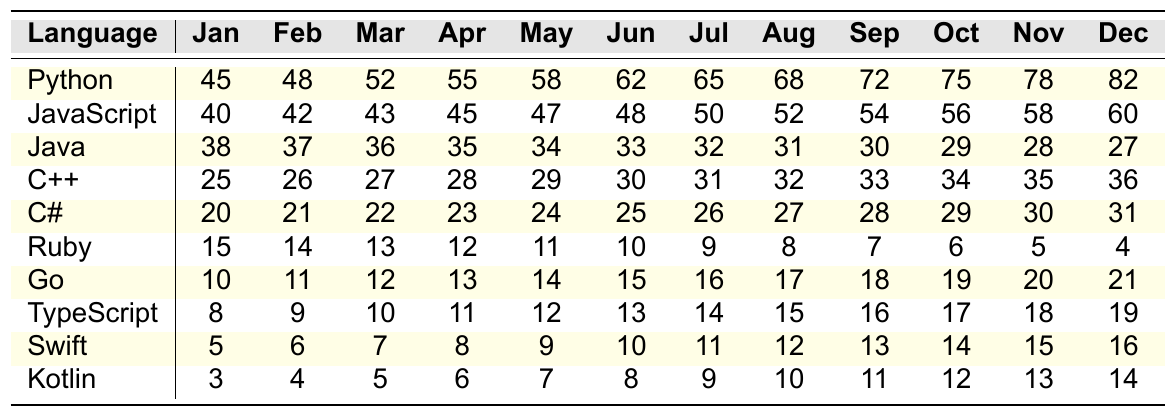What programming language showed the highest popularity in October? In October, Python has the highest value at 75, which is more than any other programming language listed.
Answer: Python Which programming language has the lowest popularity in January? In January, Kotlin has the lowest value at 3, which is the smallest among all programming languages for that month.
Answer: Kotlin What was the average popularity of JavaScript over the year? The values for JavaScript are (40 + 42 + 43 + 45 + 47 + 48 + 50 + 52 + 54 + 56 + 58 + 60) =  582. Dividing by 12 months gives an average of 582/12 = 48.5.
Answer: 48.5 Which programming language had the steepest increase in popularity from June to July? Python had an increase from 62 in June to 65 in July, while the increases for others were smaller. Notably, Go also had an increase from 15 in June to 16 in July, but Python's increase is the largest at +3.
Answer: Python Did Ruby's popularity ever exceed 20 during the year? No, Ruby's highest value is 15, which is less than 20 throughout the year.
Answer: No What is the total popularity of C++ across all months? The total popularity of C++ is calculated by summing its monthly values (25 + 26 + 27 + 28 + 29 + 30 + 31 + 32 + 33 + 34 + 35 + 36) =  366.
Answer: 366 Which language had a consistent decline in popularity every month? Java's values decreased consistently from 38 in January to 27 in December, indicating a downward trend month over month.
Answer: Java How much more popular was Python than Kotlin in December? In December, Python's popularity was 82 while Kotlin's was 14. The difference is calculated as 82 - 14 = 68.
Answer: 68 Which programming language increased in popularity every month from January to December? Go showed a steady increase every month, starting from 10 in January to 21 in December.
Answer: Go What was the total popularity of the two most popular languages (Python and JavaScript) in August? In August, Python's popularity was 68 and JavaScript's was 52. The total is 68 + 52 = 120.
Answer: 120 